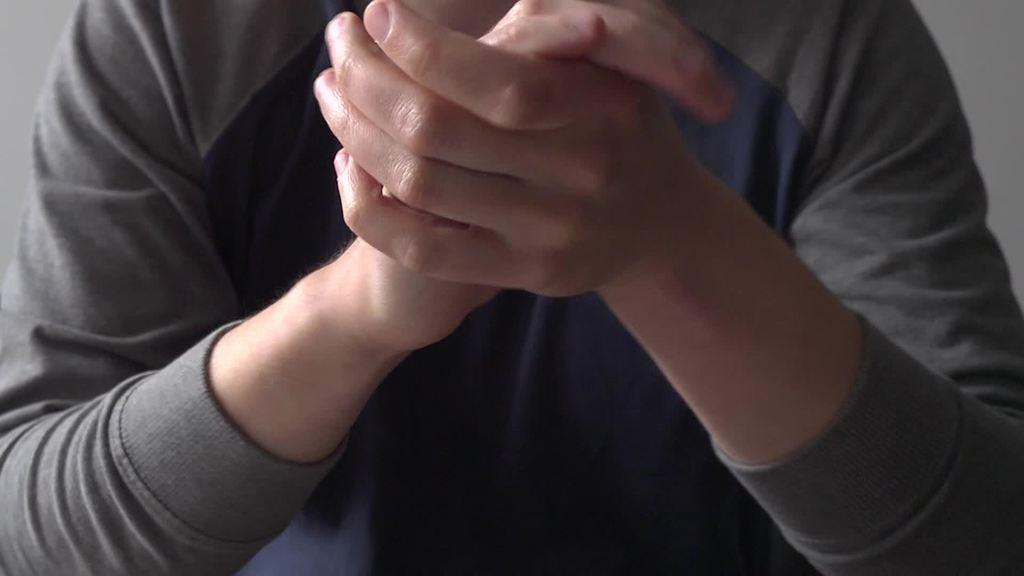What is present in the image? There is a person in the image. What is the person doing in the image? The person is holding hands. What type of air is being used by the person in the image? There is no mention of air or any specific type of air being used in the image. 